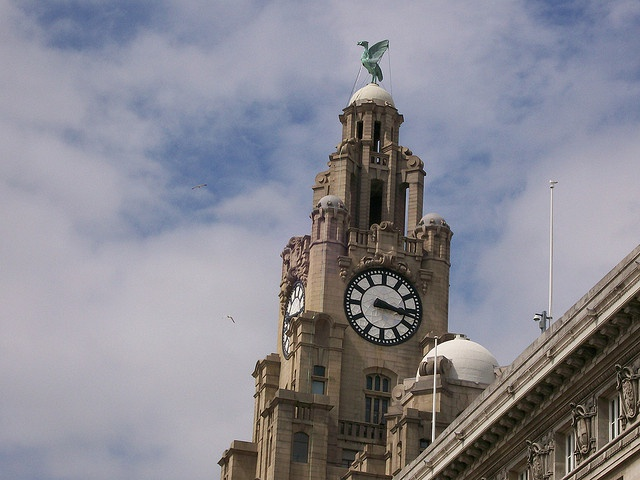Describe the objects in this image and their specific colors. I can see clock in darkgray, black, and gray tones, clock in darkgray, lightgray, gray, and black tones, bird in darkgray and gray tones, and bird in darkgray, lightgray, and gray tones in this image. 